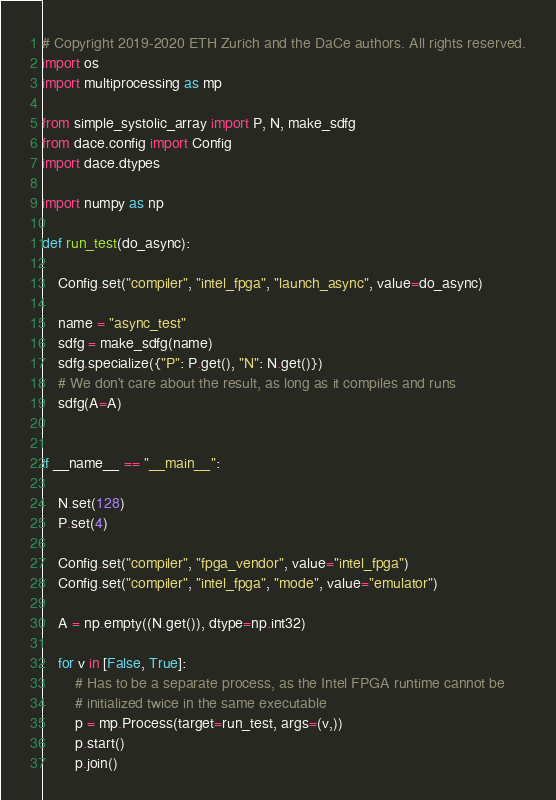Convert code to text. <code><loc_0><loc_0><loc_500><loc_500><_Python_># Copyright 2019-2020 ETH Zurich and the DaCe authors. All rights reserved.
import os
import multiprocessing as mp

from simple_systolic_array import P, N, make_sdfg
from dace.config import Config
import dace.dtypes

import numpy as np

def run_test(do_async):

    Config.set("compiler", "intel_fpga", "launch_async", value=do_async)

    name = "async_test"
    sdfg = make_sdfg(name)
    sdfg.specialize({"P": P.get(), "N": N.get()})
    # We don't care about the result, as long as it compiles and runs
    sdfg(A=A)


if __name__ == "__main__":

    N.set(128)
    P.set(4)

    Config.set("compiler", "fpga_vendor", value="intel_fpga")
    Config.set("compiler", "intel_fpga", "mode", value="emulator")

    A = np.empty((N.get()), dtype=np.int32)

    for v in [False, True]:
        # Has to be a separate process, as the Intel FPGA runtime cannot be
        # initialized twice in the same executable
        p = mp.Process(target=run_test, args=(v,))
        p.start()
        p.join()
</code> 